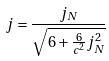<formula> <loc_0><loc_0><loc_500><loc_500>j = \frac { j _ { N } } { \sqrt { 6 + \frac { 6 } { c ^ { 2 } } j _ { N } ^ { 2 } } }</formula> 